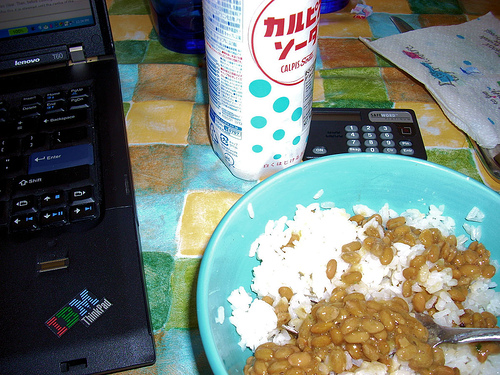Please transcribe the text in this image. GILT lenovo ThinkPad IBM 